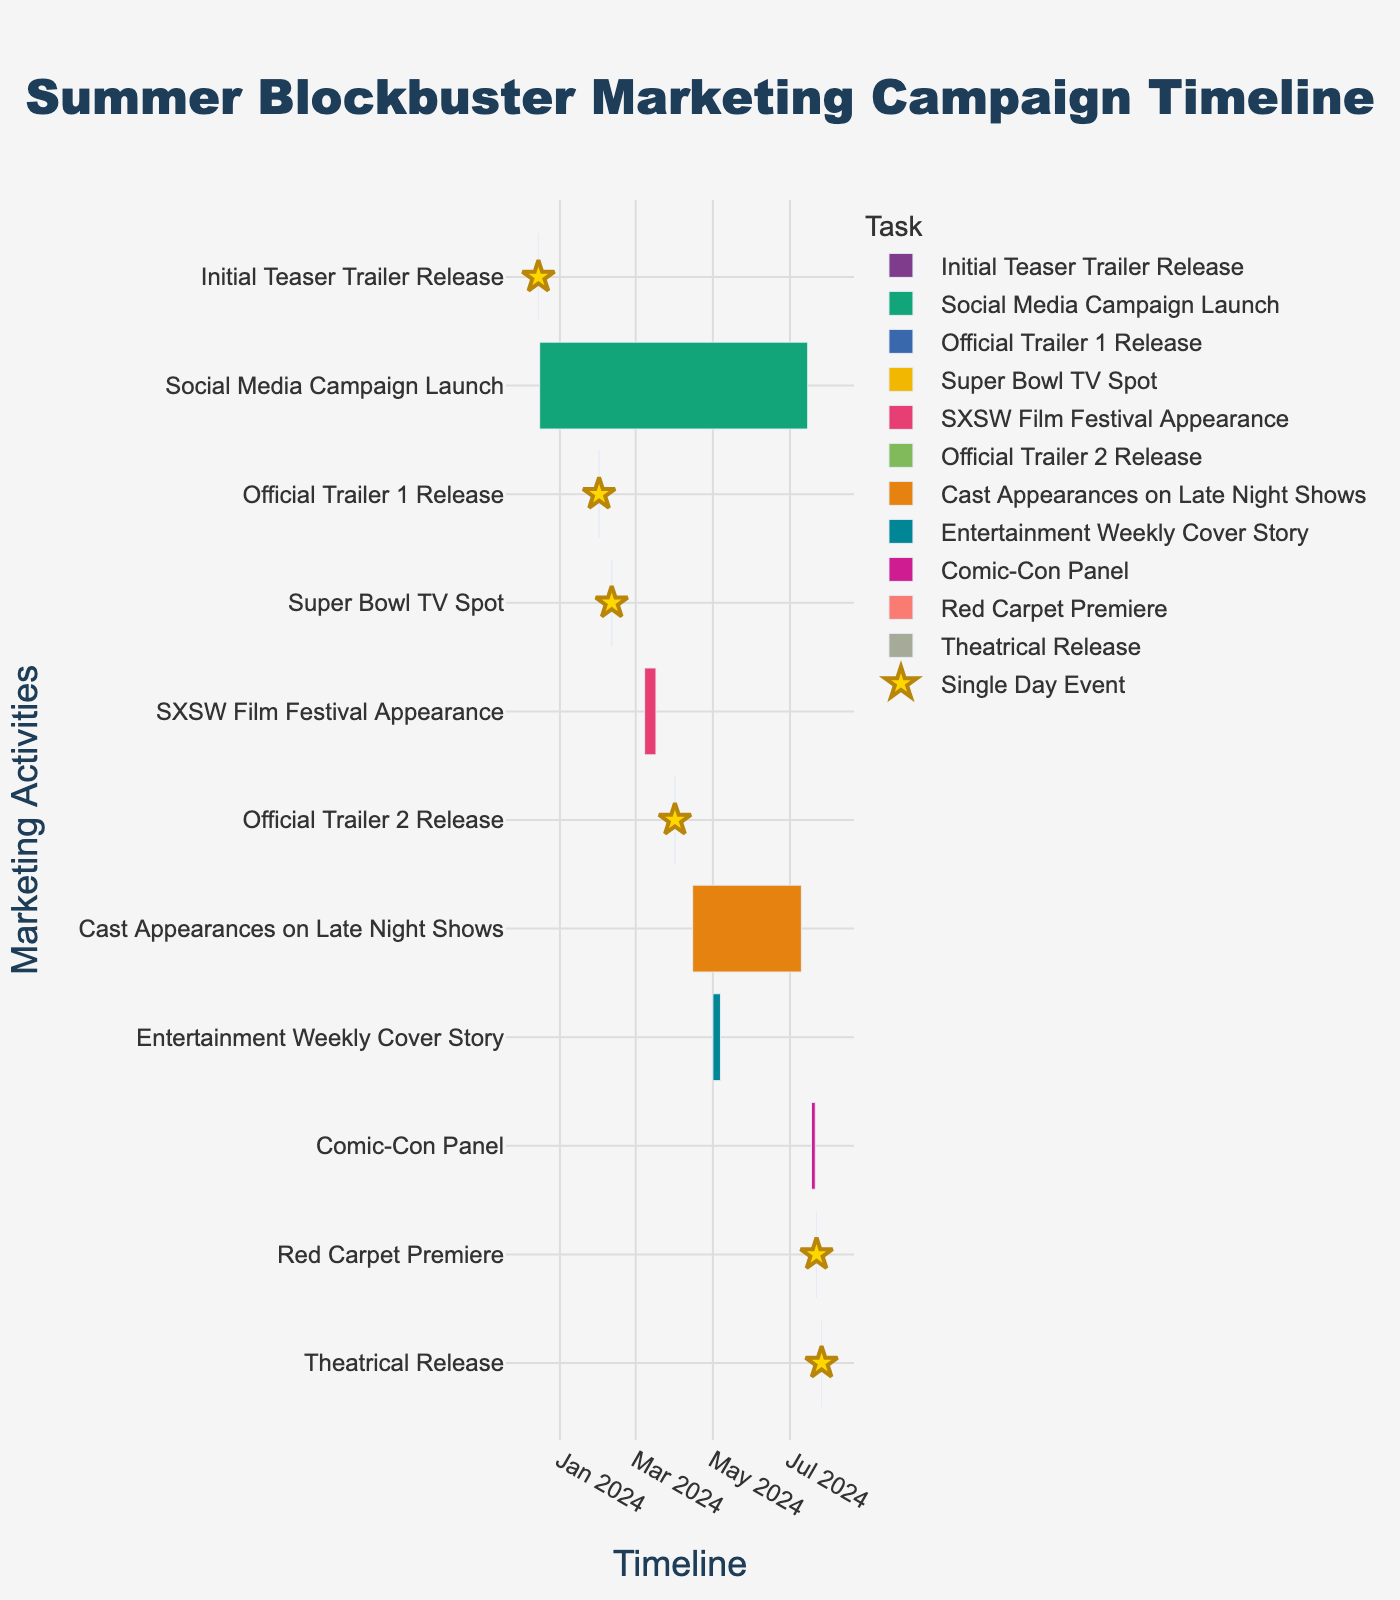What is the title of the Gantt chart? The title is usually prominently displayed at the top of the chart. In this case, the title is "Summer Blockbuster Marketing Campaign Timeline".
Answer: Summer Blockbuster Marketing Campaign Timeline When does the Social Media Campaign Launch start and end? Look at the bar corresponding to the "Social Media Campaign Launch" task on the y-axis and check its start and end points on the x-axis.
Answer: December 16, 2023, to July 15, 2024 Which task spans the longest duration? To determine the task with the longest duration, observe the length of the bars. The longest bar corresponds to the Social Media Campaign Launch.
Answer: Social Media Campaign Launch How many single-day events are there in the timeline? Single-day events are marked with star symbols. Count these symbols in the chart.
Answer: 5 What significant event happens on February 11, 2024? Locate February 11, 2024, on the x-axis and find the corresponding task on the y-axis.
Answer: Super Bowl TV Spot Which tasks occur in March 2024? Identify tasks with bars that fall into March 2024 on the x-axis; only include tasks active during this time frame.
Answer: SXSW Film Festival Appearance Compare the durations of Entertainment Weekly Cover Story and Cast Appearances on Late Night Shows. Which is longer? Calculate the duration of each task by seeing where they start and end on the x-axis. Cast Appearances on Late Night Shows span from April 15, 2024, to July 10, 2024, and Entertainment Weekly Cover Story spans from May 1, 2024, to May 7, 2024.
Answer: Cast Appearances on Late Night Shows What's the difference in days between the release of the first and second official trailers? Find the dates for both "Official Trailer 1 Release" (February 1, 2024) and "Official Trailer 2 Release" (April 1, 2024) and calculate the number of days between the two dates.
Answer: 60 days When is the Comic-Con Panel scheduled? Locate the "Comic-Con Panel" task on the y-axis and note its start and end dates on the x-axis.
Answer: July 18, 2024, to July 21, 2024 Which events are featured in July 2024 leading up to the theatrical release? Identify all tasks with bars in July 2024, showing their active periods on the x-axis, especially noting proximity to the theatrical release date of July 26, 2024.
Answer: Social Media Campaign Launch, Cast Appearances on Late Night Shows, Comic-Con Panel, Red Carpet Premiere, Theatrical Release 